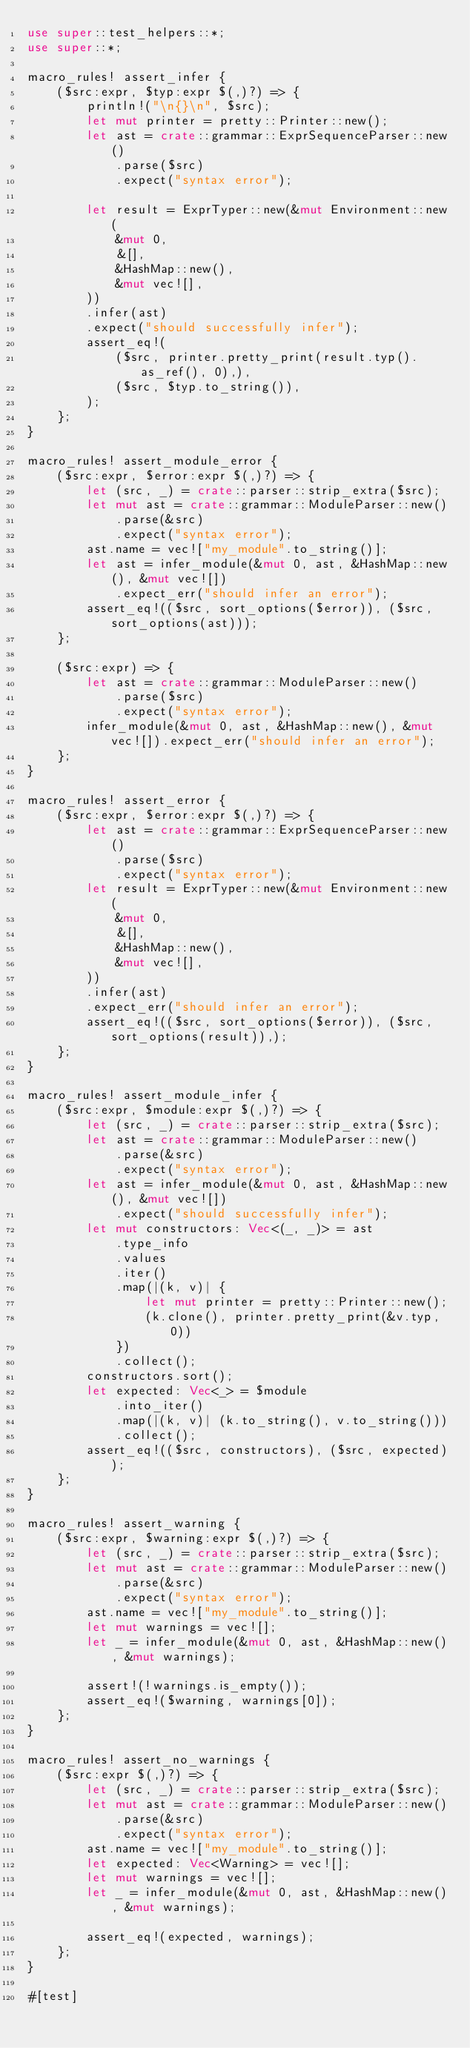Convert code to text. <code><loc_0><loc_0><loc_500><loc_500><_Rust_>use super::test_helpers::*;
use super::*;

macro_rules! assert_infer {
    ($src:expr, $typ:expr $(,)?) => {
        println!("\n{}\n", $src);
        let mut printer = pretty::Printer::new();
        let ast = crate::grammar::ExprSequenceParser::new()
            .parse($src)
            .expect("syntax error");

        let result = ExprTyper::new(&mut Environment::new(
            &mut 0,
            &[],
            &HashMap::new(),
            &mut vec![],
        ))
        .infer(ast)
        .expect("should successfully infer");
        assert_eq!(
            ($src, printer.pretty_print(result.typ().as_ref(), 0),),
            ($src, $typ.to_string()),
        );
    };
}

macro_rules! assert_module_error {
    ($src:expr, $error:expr $(,)?) => {
        let (src, _) = crate::parser::strip_extra($src);
        let mut ast = crate::grammar::ModuleParser::new()
            .parse(&src)
            .expect("syntax error");
        ast.name = vec!["my_module".to_string()];
        let ast = infer_module(&mut 0, ast, &HashMap::new(), &mut vec![])
            .expect_err("should infer an error");
        assert_eq!(($src, sort_options($error)), ($src, sort_options(ast)));
    };

    ($src:expr) => {
        let ast = crate::grammar::ModuleParser::new()
            .parse($src)
            .expect("syntax error");
        infer_module(&mut 0, ast, &HashMap::new(), &mut vec![]).expect_err("should infer an error");
    };
}

macro_rules! assert_error {
    ($src:expr, $error:expr $(,)?) => {
        let ast = crate::grammar::ExprSequenceParser::new()
            .parse($src)
            .expect("syntax error");
        let result = ExprTyper::new(&mut Environment::new(
            &mut 0,
            &[],
            &HashMap::new(),
            &mut vec![],
        ))
        .infer(ast)
        .expect_err("should infer an error");
        assert_eq!(($src, sort_options($error)), ($src, sort_options(result)),);
    };
}

macro_rules! assert_module_infer {
    ($src:expr, $module:expr $(,)?) => {
        let (src, _) = crate::parser::strip_extra($src);
        let ast = crate::grammar::ModuleParser::new()
            .parse(&src)
            .expect("syntax error");
        let ast = infer_module(&mut 0, ast, &HashMap::new(), &mut vec![])
            .expect("should successfully infer");
        let mut constructors: Vec<(_, _)> = ast
            .type_info
            .values
            .iter()
            .map(|(k, v)| {
                let mut printer = pretty::Printer::new();
                (k.clone(), printer.pretty_print(&v.typ, 0))
            })
            .collect();
        constructors.sort();
        let expected: Vec<_> = $module
            .into_iter()
            .map(|(k, v)| (k.to_string(), v.to_string()))
            .collect();
        assert_eq!(($src, constructors), ($src, expected));
    };
}

macro_rules! assert_warning {
    ($src:expr, $warning:expr $(,)?) => {
        let (src, _) = crate::parser::strip_extra($src);
        let mut ast = crate::grammar::ModuleParser::new()
            .parse(&src)
            .expect("syntax error");
        ast.name = vec!["my_module".to_string()];
        let mut warnings = vec![];
        let _ = infer_module(&mut 0, ast, &HashMap::new(), &mut warnings);

        assert!(!warnings.is_empty());
        assert_eq!($warning, warnings[0]);
    };
}

macro_rules! assert_no_warnings {
    ($src:expr $(,)?) => {
        let (src, _) = crate::parser::strip_extra($src);
        let mut ast = crate::grammar::ModuleParser::new()
            .parse(&src)
            .expect("syntax error");
        ast.name = vec!["my_module".to_string()];
        let expected: Vec<Warning> = vec![];
        let mut warnings = vec![];
        let _ = infer_module(&mut 0, ast, &HashMap::new(), &mut warnings);

        assert_eq!(expected, warnings);
    };
}

#[test]</code> 